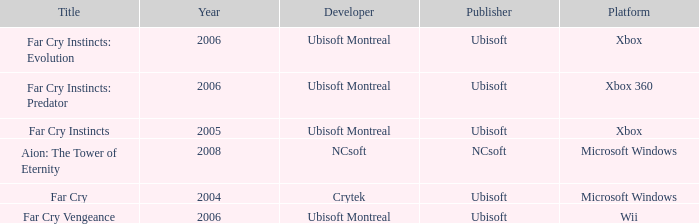Which title has a year prior to 2008 and xbox 360 as the platform? Far Cry Instincts: Predator. 